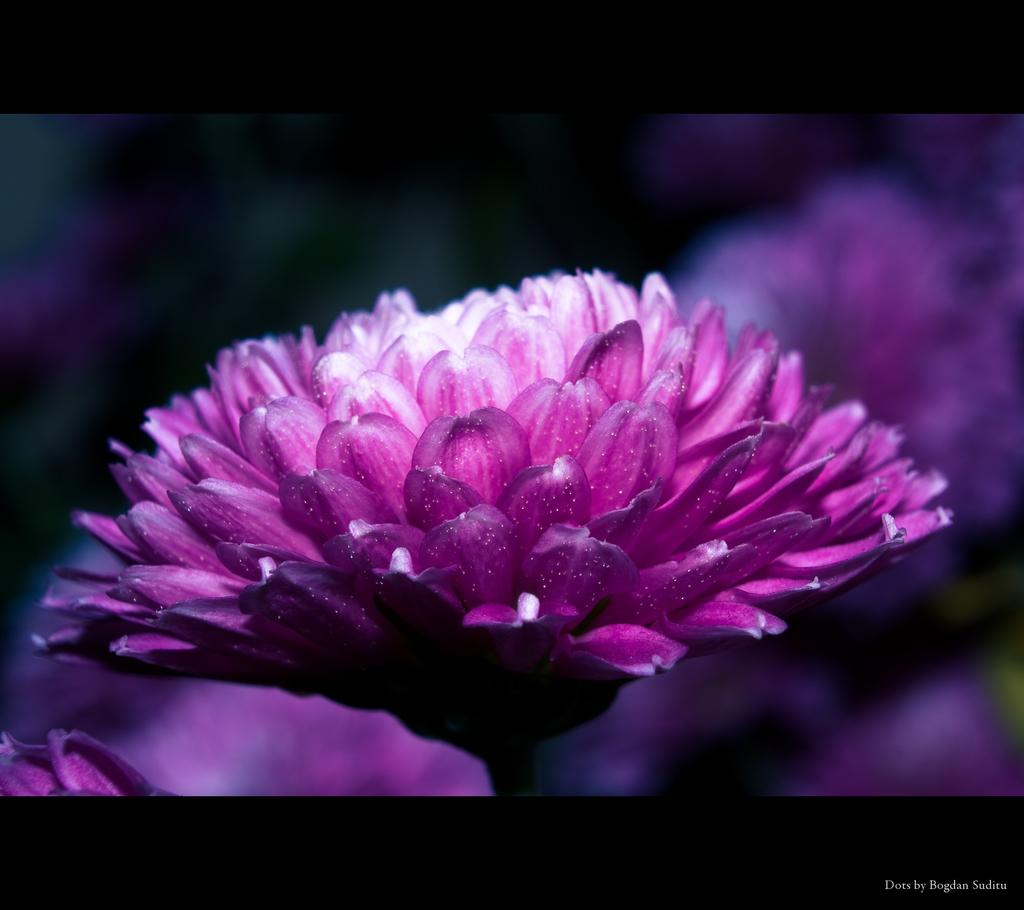What is the main subject of the image? There is a flower in the image. How would you describe the background of the image? The background of the image is blurred. Is there any additional information or text visible in the image? Yes, there is a watermark at the bottom of the image. Can you tell me how many drinks are being sold at the market in the image? There is no market or drinks present in the image; it features a flower with a blurred background and a watermark. What type of tiger can be seen interacting with the flower in the image? There is no tiger present in the image; it only features a flower and a blurred background. 